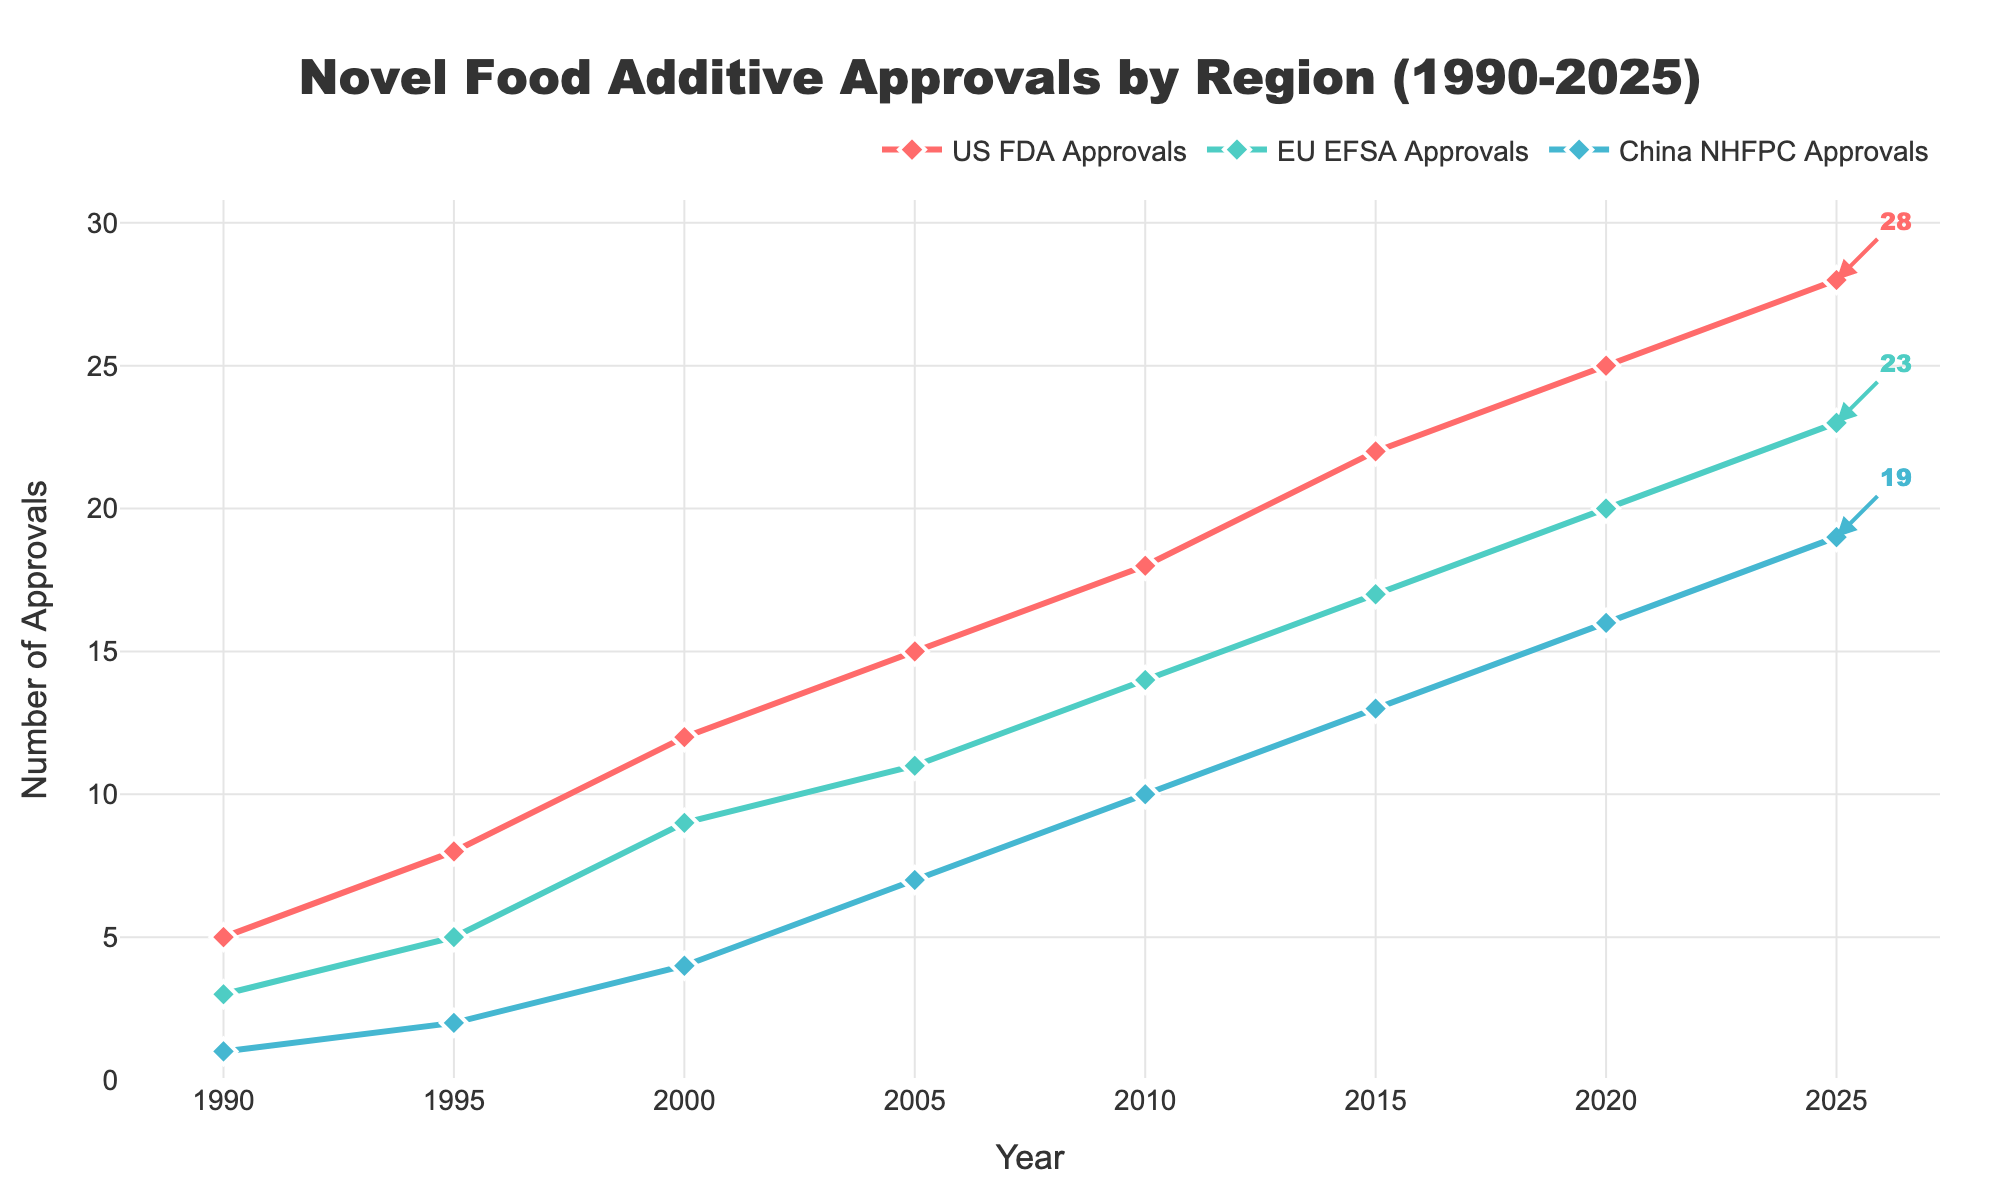What was the total number of approvals in the US, EU, and China in 2005? In 2005, the number of approvals were 15 for the US, 11 for the EU, and 7 for China. Summing these values yields 15 + 11 + 7 = 33.
Answer: 33 By how much did FDA approvals in the US increase between 1990 and 2025? FDA approvals in the US were 5 in 1990 and increased to 28 in 2025. The difference is 28 - 5 = 23.
Answer: 23 Which region had the highest number of approvals in 2020? In 2020, the US had 25 approvals, the EU had 20, and China had 16. The US had the highest number of approvals.
Answer: US Compare the growth in approvals between the EU and China from 1990 to 2025. Which region saw a greater increase? In 1990, the EU had 3 approvals, and it grew to 23 in 2025, an increase of 23 - 3 = 20. China had 1 approval in 1990 and 19 in 2025, an increase of 19 - 1 = 18. The EU saw a greater increase.
Answer: EU What is the average number of approvals by the EU between 1990 and 2025? The number of EU approvals are 3, 5, 9, 11, 14, 17, 20, and 23. Summing these values gives 3 + 5 + 9 + 11 + 14 + 17 + 20 + 23 = 102. Dividing by the 8 years: 102 / 8 = 12.75.
Answer: 12.75 Which region experienced the most consistent growth in approvals from 1990 to 2025? By observing the slopes and intervals between years, the US seems to have the most linear and consistent increase in approvals over the period.
Answer: US From the data, how many more approvals does the US have compared to the EU in 2025? In 2025, the US had 28 approvals, and the EU had 23, so the difference is 28 - 23 = 5.
Answer: 5 What is the overall trend in the number of approvals across all three regions from 1990 to 2025? The overall trend in all three regions shows a steady increase in the number of approvals over time from 1990 to 2025.
Answer: Steady increase 